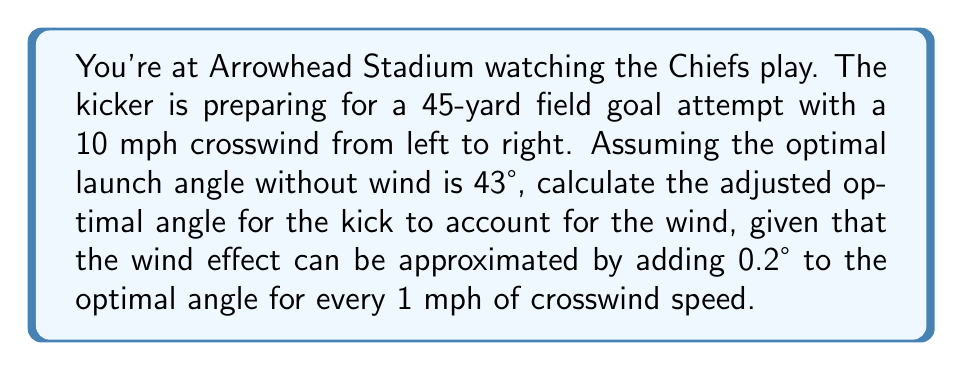Can you solve this math problem? To solve this problem, we'll follow these steps:

1. Identify the given information:
   - Optimal launch angle without wind: 43°
   - Crosswind speed: 10 mph
   - Wind effect: 0.2° added for every 1 mph of crosswind

2. Calculate the angle adjustment due to wind:
   $$\text{Angle adjustment} = \text{Wind speed} \times \text{Adjustment per mph}$$
   $$\text{Angle adjustment} = 10 \text{ mph} \times 0.2°/\text{mph} = 2°$$

3. Add the angle adjustment to the optimal angle without wind:
   $$\text{Adjusted optimal angle} = \text{Optimal angle without wind} + \text{Angle adjustment}$$
   $$\text{Adjusted optimal angle} = 43° + 2° = 45°$$

Therefore, the adjusted optimal angle for the field goal kick, accounting for the crosswind, is 45°.
Answer: 45° 